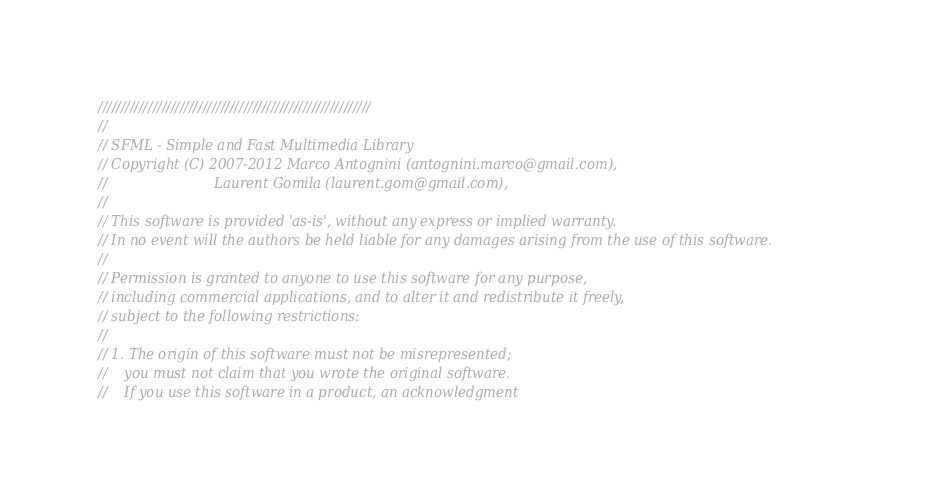Convert code to text. <code><loc_0><loc_0><loc_500><loc_500><_ObjectiveC_>////////////////////////////////////////////////////////////
//
// SFML - Simple and Fast Multimedia Library
// Copyright (C) 2007-2012 Marco Antognini (antognini.marco@gmail.com), 
//                         Laurent Gomila (laurent.gom@gmail.com), 
//
// This software is provided 'as-is', without any express or implied warranty.
// In no event will the authors be held liable for any damages arising from the use of this software.
//
// Permission is granted to anyone to use this software for any purpose,
// including commercial applications, and to alter it and redistribute it freely,
// subject to the following restrictions:
//
// 1. The origin of this software must not be misrepresented;
//    you must not claim that you wrote the original software.
//    If you use this software in a product, an acknowledgment</code> 